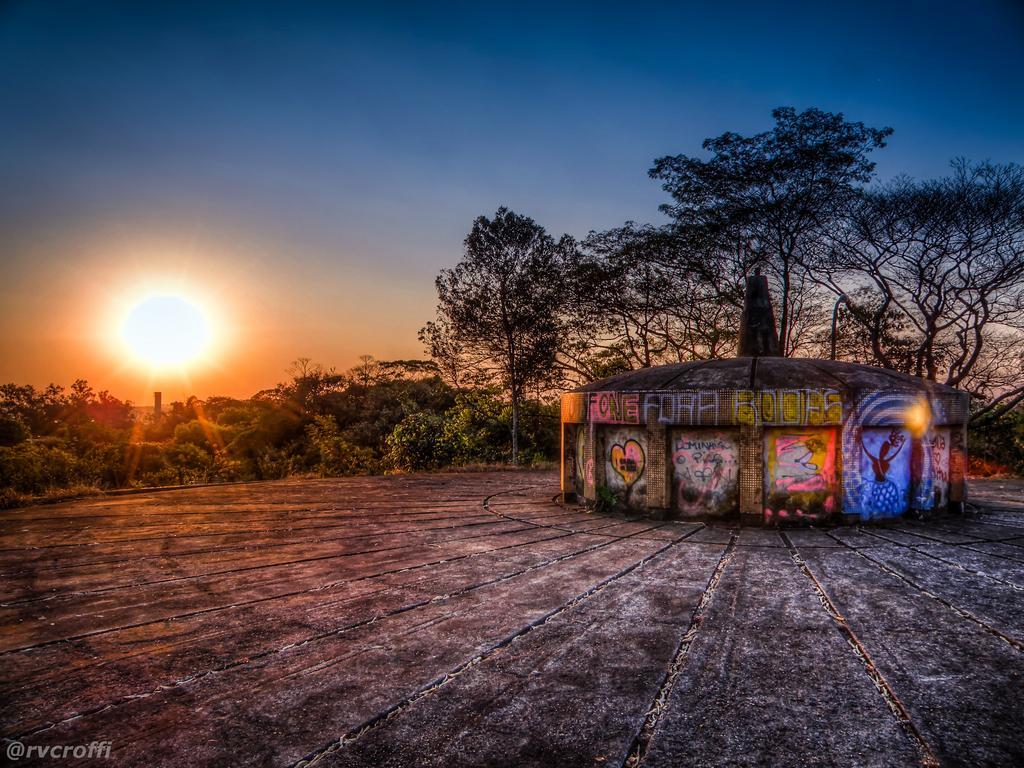Please provide a concise description of this image. In this picture I can see graffiti on the walls of an architecture, and there are plants, trees, sun in the sky , there is a watermark on the image. 